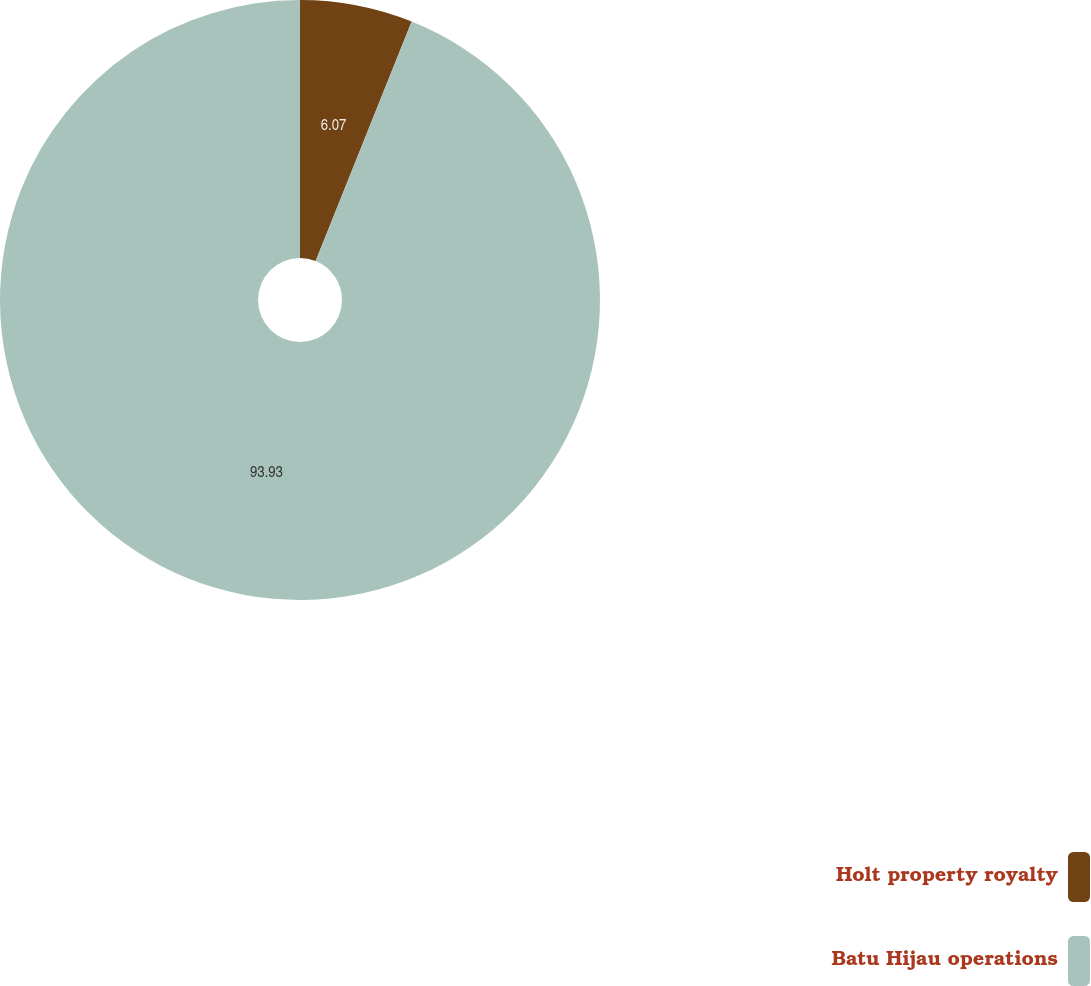Convert chart. <chart><loc_0><loc_0><loc_500><loc_500><pie_chart><fcel>Holt property royalty<fcel>Batu Hijau operations<nl><fcel>6.07%<fcel>93.93%<nl></chart> 